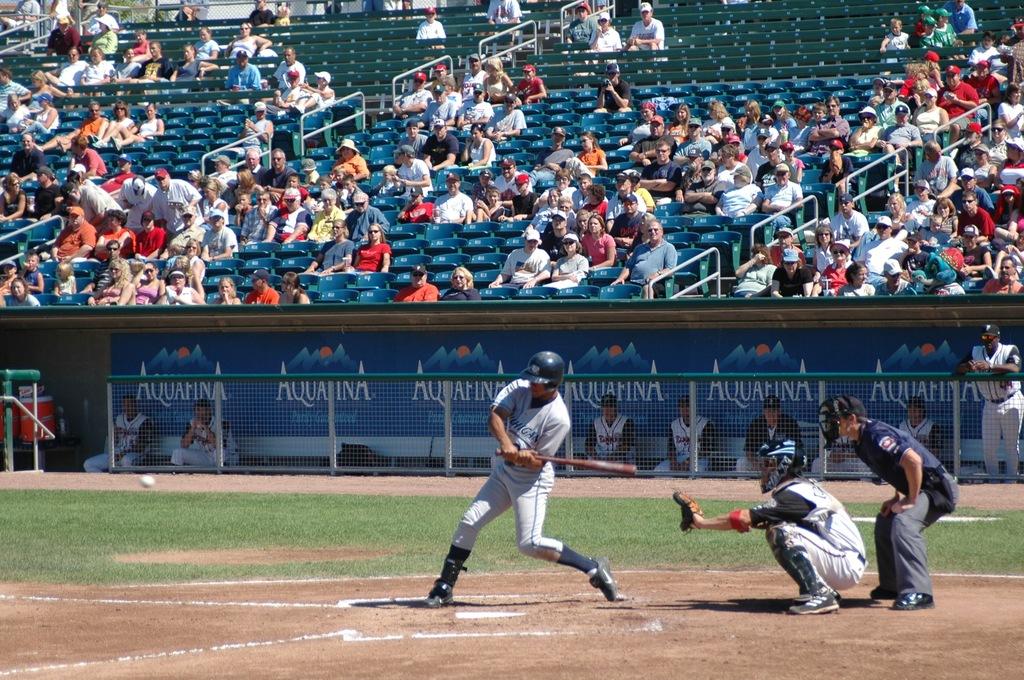What brand of water is advertised in the dugout?
Ensure brevity in your answer.  Aquafina. Which team do these guys play for?
Your response must be concise. Unanswerable. 